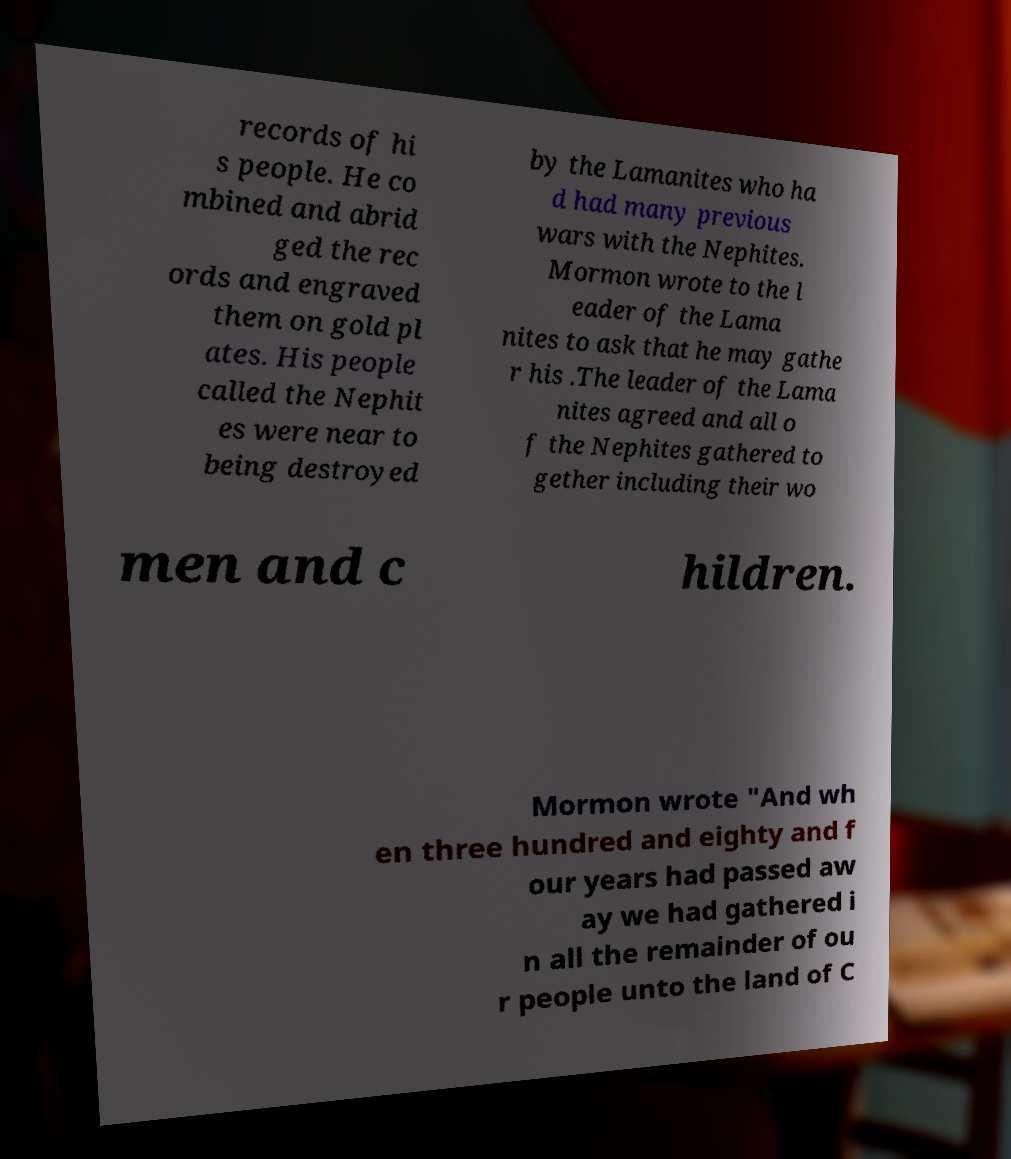There's text embedded in this image that I need extracted. Can you transcribe it verbatim? records of hi s people. He co mbined and abrid ged the rec ords and engraved them on gold pl ates. His people called the Nephit es were near to being destroyed by the Lamanites who ha d had many previous wars with the Nephites. Mormon wrote to the l eader of the Lama nites to ask that he may gathe r his .The leader of the Lama nites agreed and all o f the Nephites gathered to gether including their wo men and c hildren. Mormon wrote "And wh en three hundred and eighty and f our years had passed aw ay we had gathered i n all the remainder of ou r people unto the land of C 